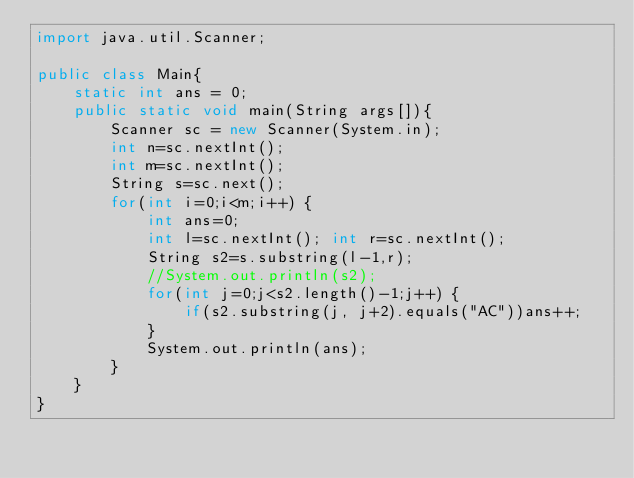<code> <loc_0><loc_0><loc_500><loc_500><_Java_>import java.util.Scanner;

public class Main{
	static int ans = 0;
	public static void main(String args[]){
		Scanner sc = new Scanner(System.in);
		int n=sc.nextInt();
		int m=sc.nextInt();
		String s=sc.next();
		for(int i=0;i<m;i++) {
			int ans=0;
			int l=sc.nextInt(); int r=sc.nextInt();
			String s2=s.substring(l-1,r);
			//System.out.println(s2);
			for(int j=0;j<s2.length()-1;j++) {
				if(s2.substring(j, j+2).equals("AC"))ans++;
			}
			System.out.println(ans);
		}
	}
}
</code> 